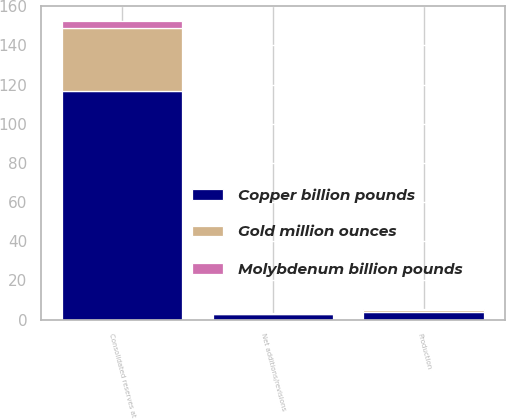<chart> <loc_0><loc_0><loc_500><loc_500><stacked_bar_chart><ecel><fcel>Consolidated reserves at<fcel>Net additions/revisions<fcel>Production<nl><fcel>Copper billion pounds<fcel>116.5<fcel>2.9<fcel>3.7<nl><fcel>Gold million ounces<fcel>32.5<fcel>0.2<fcel>1.4<nl><fcel>Molybdenum billion pounds<fcel>3.42<fcel>0.11<fcel>0.08<nl></chart> 